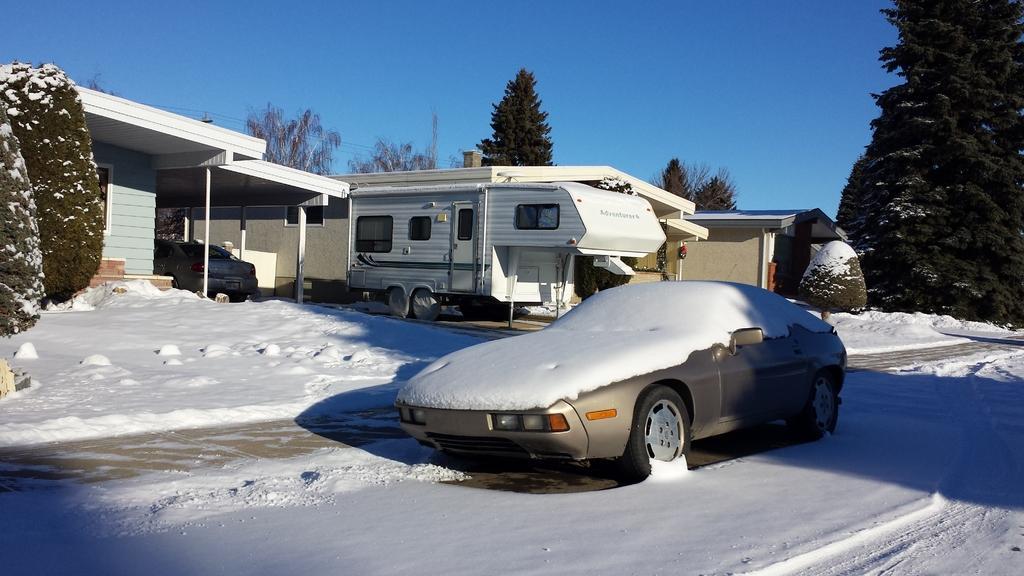Could you give a brief overview of what you see in this image? In this picture there is a car on the road, at the top of the car we can see the snow. At the back there is a truck near to the building. On the left we can see car in front of the door. In the background we can see the wires, trees and sky. 